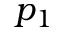<formula> <loc_0><loc_0><loc_500><loc_500>p _ { 1 }</formula> 